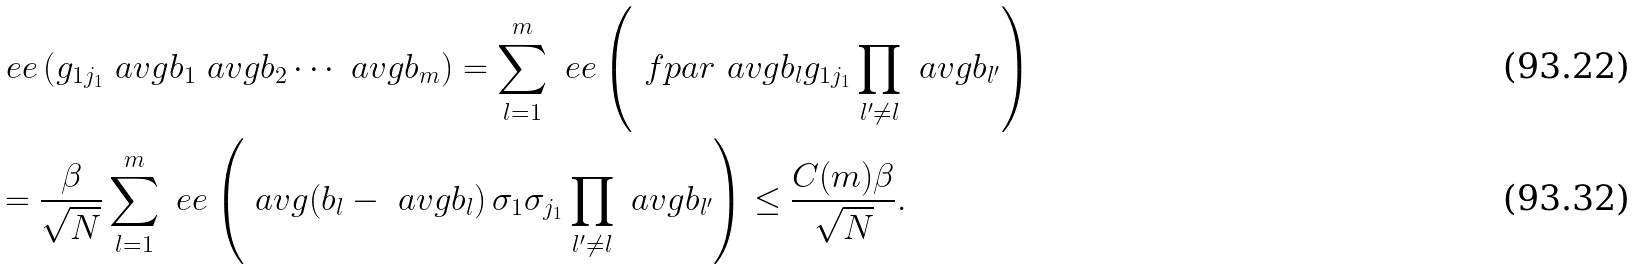Convert formula to latex. <formula><loc_0><loc_0><loc_500><loc_500>& \ e e \left ( g _ { 1 j _ { 1 } } \ a v g { b _ { 1 } } \ a v g { b _ { 2 } } \cdots \ a v g { b _ { m } } \right ) = \sum _ { l = 1 } ^ { m } \ e e \left ( \ f p a r { \ a v g { b _ { l } } } { g _ { 1 j _ { 1 } } } \prod _ { l ^ { \prime } \ne l } \ a v g { b _ { l ^ { \prime } } } \right ) \\ & = \frac { \beta } { \sqrt { N } } \sum _ { l = 1 } ^ { m } \ e e \left ( \ a v g { \left ( b _ { l } - \ a v g { b _ { l } } \right ) \sigma _ { 1 } \sigma _ { j _ { 1 } } } \prod _ { l ^ { \prime } \ne l } \ a v g { b _ { l ^ { \prime } } } \right ) \leq \frac { C ( m ) \beta } { \sqrt { N } } .</formula> 